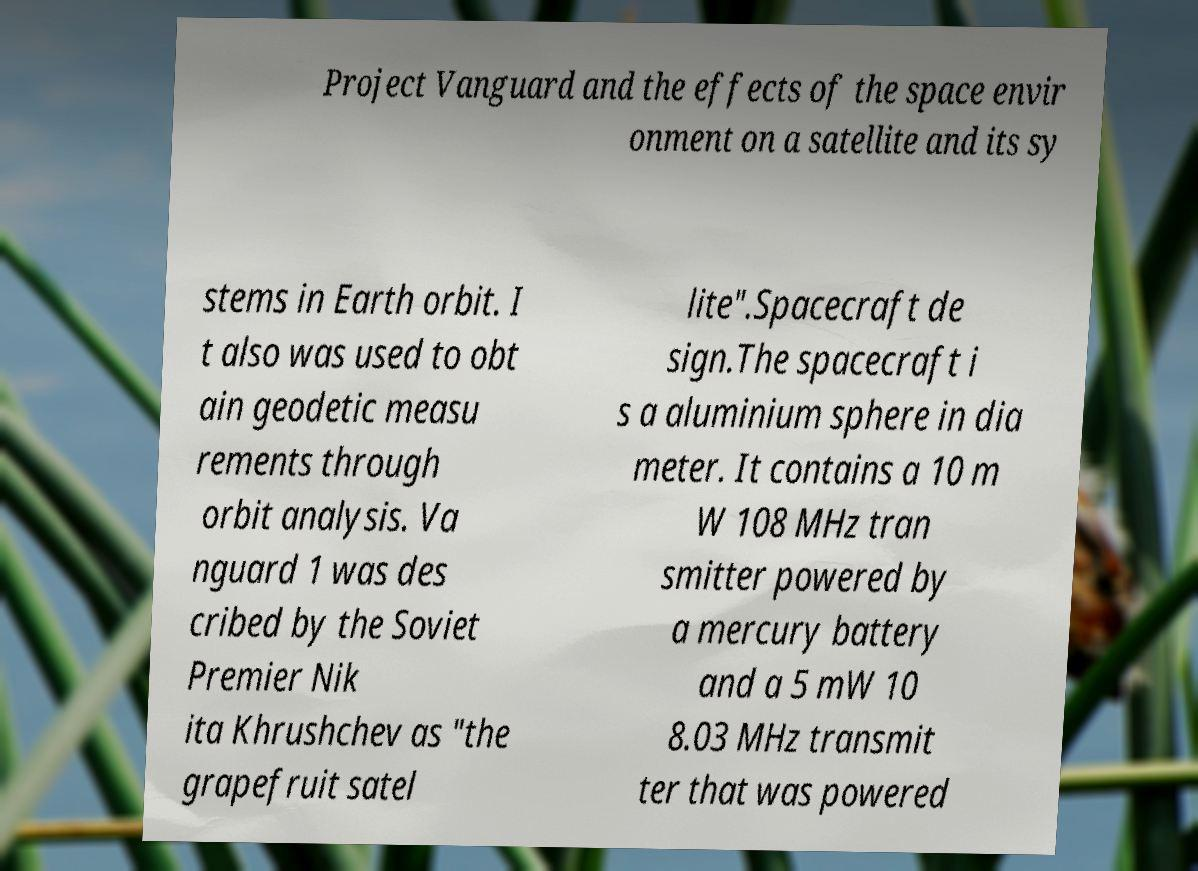What messages or text are displayed in this image? I need them in a readable, typed format. Project Vanguard and the effects of the space envir onment on a satellite and its sy stems in Earth orbit. I t also was used to obt ain geodetic measu rements through orbit analysis. Va nguard 1 was des cribed by the Soviet Premier Nik ita Khrushchev as "the grapefruit satel lite".Spacecraft de sign.The spacecraft i s a aluminium sphere in dia meter. It contains a 10 m W 108 MHz tran smitter powered by a mercury battery and a 5 mW 10 8.03 MHz transmit ter that was powered 